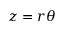Convert formula to latex. <formula><loc_0><loc_0><loc_500><loc_500>z = r \theta</formula> 